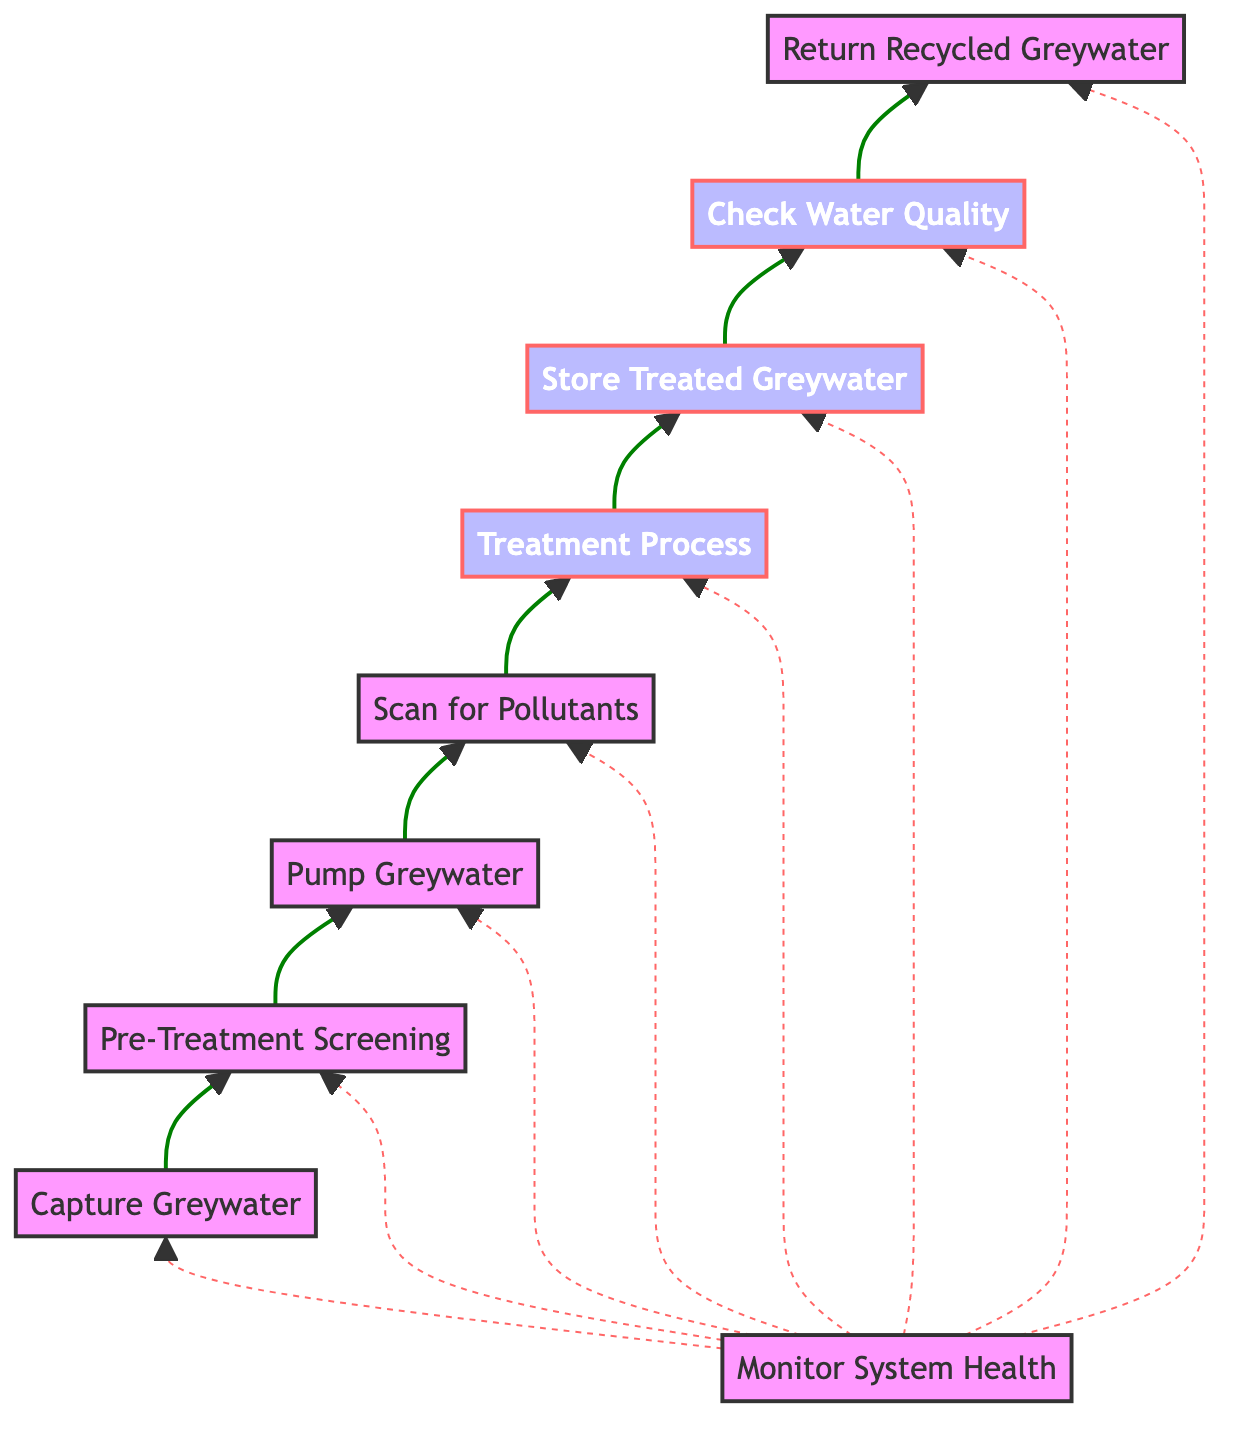What is the first step in the greywater recycling system? The diagram indicates that the first step is "Capture Greywater," which is the starting node of the flowchart. This node begins the process of reclaiming water for reuse.
Answer: Capture Greywater How many main steps are there in the treatment process? The diagram outlines eight main steps from "Capture Greywater" to "Return Recycled Greywater." Each step represents a significant action within the process of greywater recycling.
Answer: Eight What comes after "Pre-Treatment Screening"? The flowchart shows that after "Pre-Treatment Screening," the next step is "Pump Greywater." This indicates that screened greywater is then moved for further treatment.
Answer: Pump Greywater Which process involves storing the greywater? In the diagram, the step labeled "Store Treated Greywater" is where the greywater is stored after it has undergone the treatment process, indicating that treated water is kept for future use.
Answer: Store Treated Greywater What step verifies that greywater meets safety standards? The flowchart indicates that "Check Water Quality" is the process where the quality of the stored greywater is assessed to ensure safety standards are met prior to reuse.
Answer: Check Water Quality Which node has a dashed line indicating monitoring? The node labeled "Monitor System Health" is connected with dashed lines to all other nodes, signifying its role in supervisory oversight over the entire greywater recycling process.
Answer: Monitor System Health What action directly follows the "Treatment Process"? According to the diagram, the step that follows the "Treatment Process" is "Store Treated Greywater," indicating that once the treatment is complete, the greywater is stored.
Answer: Store Treated Greywater Which nodes are involved in the treatment of greywater? The nodes related to treatment are "Scan for Pollutants," "Treatment Process," and "Check Water Quality." These three steps collectively encompass the treatment phase of greywater recycling.
Answer: Scan for Pollutants, Treatment Process, Check Water Quality What is the last step in the greywater recycling process? The final step of the process is "Return Recycled Greywater," where the treated water is sent back into use within construction processes. This indicates the completion of the cycle.
Answer: Return Recycled Greywater 